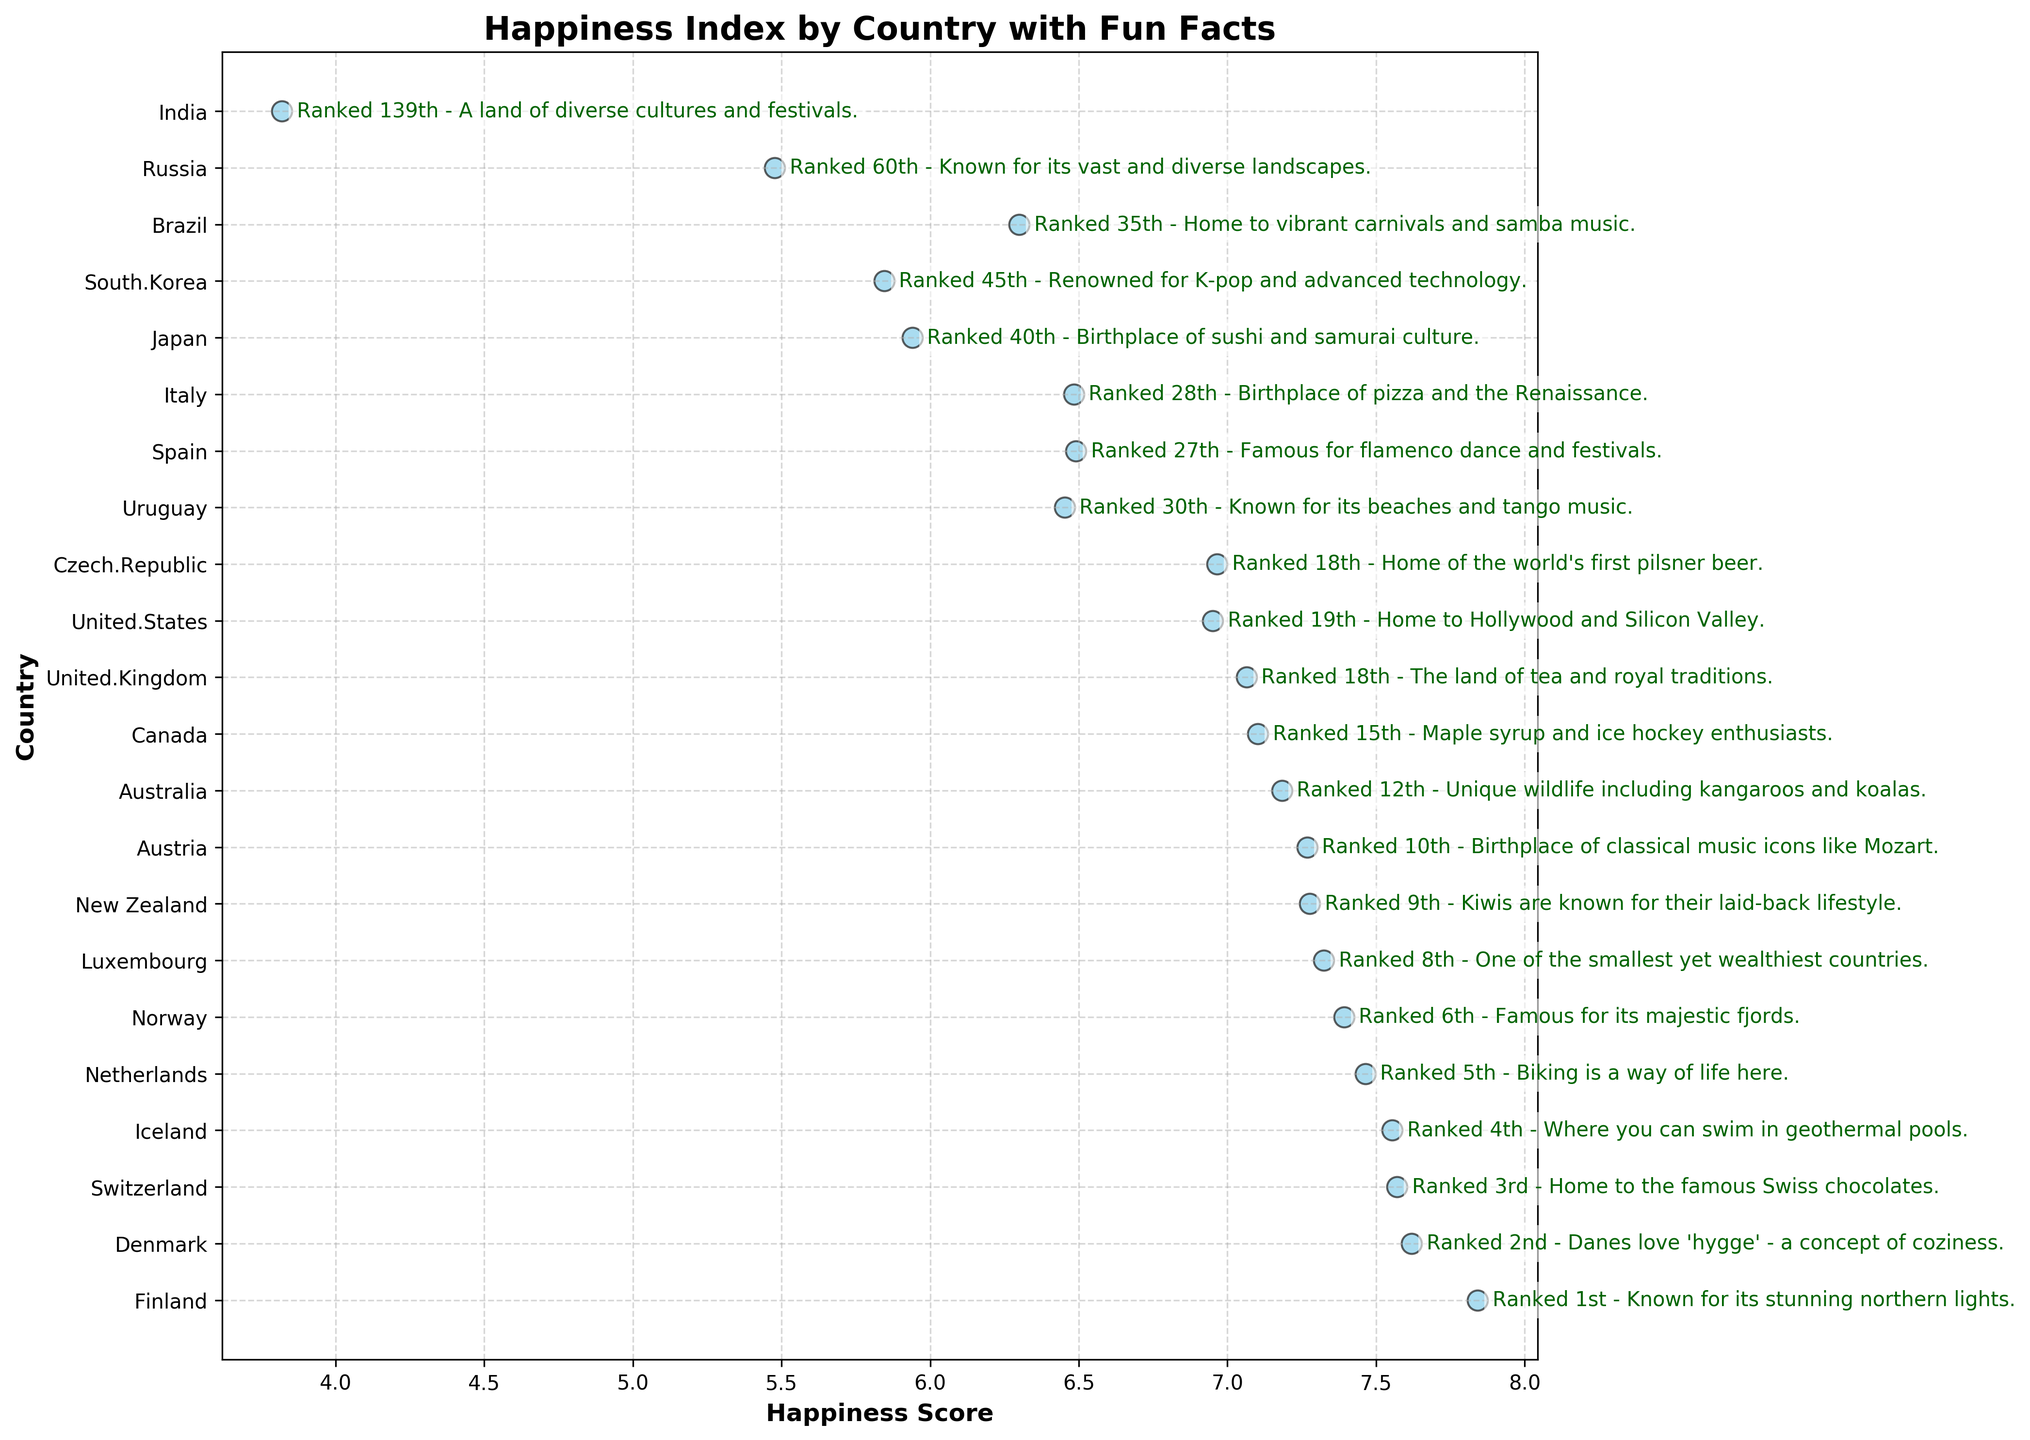Which country has the highest happiness score and what fun fact is highlighted for it? To find the highest happiness score, we look at the scatter plot and identify the country with the furthest right point. The annotation for Finland, which is this country, mentions, "Known for its stunning northern lights."
Answer: Finland - Known for its stunning northern lights Comparing Denmark and Switzerland, which one has a higher happiness score and what are their fun facts? By observing the positions of Denmark and Switzerland on the x-axis, we see Denmark has a score of 7.620, which is slightly higher than Switzerland’s score of 7.571. For fun facts, Denmark's annotation mentions "Danes love 'hygge' - a concept of coziness" and Switzerland’s mentions "Home to the famous Swiss chocolates."
Answer: Denmark - Danes love 'hygge' - a concept of coziness What is the average happiness score of the Nordic countries (Finland, Denmark, Iceland, Norway)? First, we identify the scores: Finland (7.842), Denmark (7.620), Iceland (7.554), and Norway (7.392). Adding these gives 30.408. Dividing this sum by 4 (the number of countries) results in an average score of 7.602.
Answer: 7.602 How far apart are Luxembourg and New Zealand in terms of their happiness scores, and what are their rankings? Luxembourg has a happiness score of 7.324 and New Zealand has 7.277. The difference between them is 7.324 - 7.277 = 0.047. Luxembourg is ranked 8th, and New Zealand is ranked 9th.
Answer: 0.047 - Luxembourg 8th, New Zealand 9th Which country has the fun fact about “swim in geothermal pools” and what is its happiness score? The annotation mentioning "swim in geothermal pools" refers to Iceland. By finding Iceland on the plot, we see it has a happiness score of 7.554.
Answer: Iceland - 7.554 What is the visual difference between the annotation for Canada and the United Kingdom in terms of happiness score and color used? Canada's happiness score is 7.103 and that of the United Kingdom is 7.064. Canada's score is slightly higher. The color used for the annotations is consistently dark green for both countries, so no difference in color.
Answer: Canada - 7.103, United Kingdom - 7.064 How many countries have happiness scores greater than 7.0, and name two of them with their fun facts? By counting the points to the right of the 7.0 mark on the x-axis, we find 11 countries in total. Two examples are Finland with the fun fact "Known for its stunning northern lights" and Denmark with "Danes love 'hygge' - a concept of coziness."
Answer: 11 - Finland, Denmark Which country with a happiness score lower than 6.0 is known for K-pop and advanced technology, and what is its exact ranking? Evaluating the happiness scores, South Korea has a score of 5.845. Its annotation mentions "Renowned for K-pop and advanced technology," and its ranking is 45th.
Answer: South Korea - 45th 